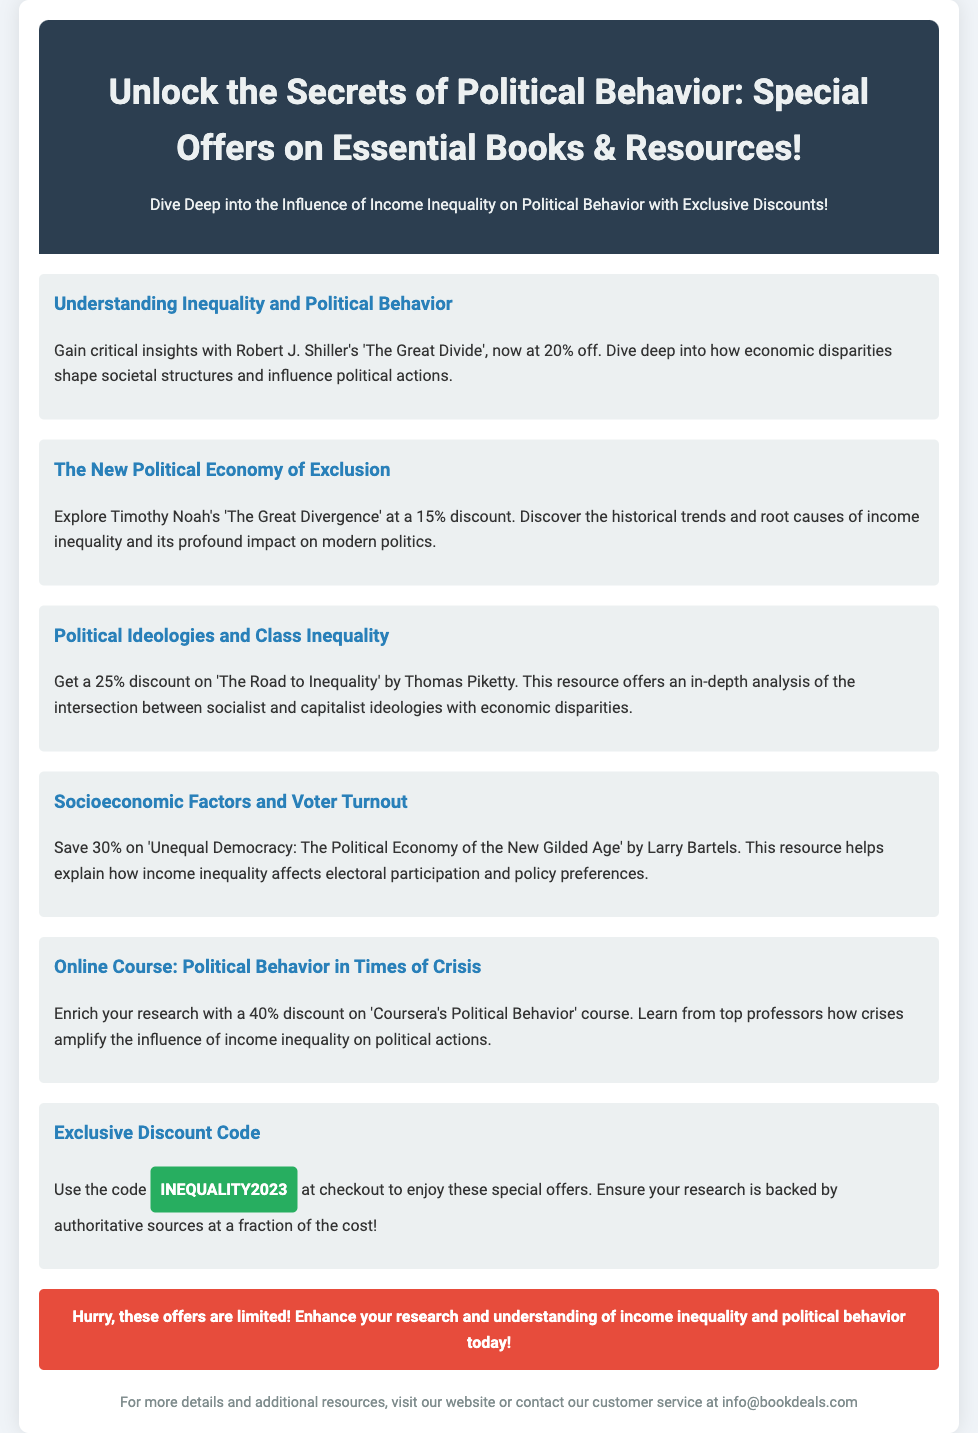What is the title of the first book offered? The first book listed in the offers is 'The Great Divide' by Robert J. Shiller.
Answer: 'The Great Divide' What discount is available for 'The Great Divergence'? The document mentions a discount of 15% for 'The Great Divergence' by Timothy Noah.
Answer: 15% Which author wrote 'The Road to Inequality'? The author of 'The Road to Inequality' is Thomas Piketty.
Answer: Thomas Piketty What is the highest discount percentage offered for the resources? The document states that the online course has the highest discount of 40%.
Answer: 40% What is the exclusive discount code mentioned? The advertisement includes the discount code 'INEQUALITY2023' for special offers.
Answer: INEQUALITY2023 Which book discusses socioeconomic factors and voter turnout? The book addressing this topic is 'Unequal Democracy: The Political Economy of the New Gilded Age' by Larry Bartels.
Answer: 'Unequal Democracy: The Political Economy of the New Gilded Age' How much can you save on the course 'Political Behavior in Times of Crisis'? The document lists a savings of 40% on this course.
Answer: 40% What is the main theme of the advertisement? The advertisement promotes offers on books and resources related to political behavior and income inequality.
Answer: Political behavior and income inequality How can customers inquire for more details according to the document? Customers can contact customer service at the provided email address info@bookdeals.com for more information.
Answer: info@bookdeals.com 